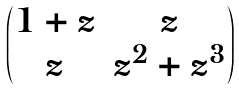<formula> <loc_0><loc_0><loc_500><loc_500>\begin{pmatrix} 1 + z & z \\ z & z ^ { 2 } + z ^ { 3 } \end{pmatrix}</formula> 